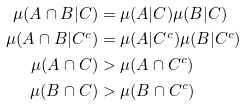<formula> <loc_0><loc_0><loc_500><loc_500>\mu ( A \cap B | C ) & = \mu ( A | C ) \mu ( B | C ) \\ \mu ( A \cap B | C ^ { c } ) & = \mu ( A | C ^ { c } ) \mu ( B | C ^ { c } ) \\ \mu ( A \cap C ) & > \mu ( A \cap C ^ { c } ) \\ \mu ( B \cap C ) & > \mu ( B \cap C ^ { c } )</formula> 